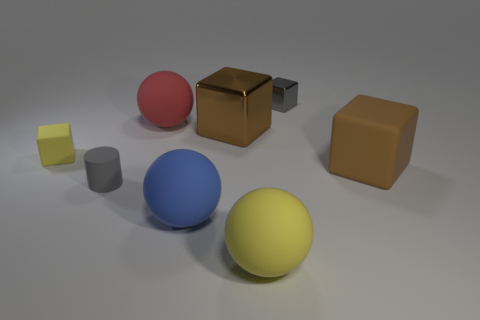There is a small object that is both to the right of the tiny yellow rubber object and behind the big matte block; what material is it made of? The small object in question, positioned to the right of the tiny yellow rubber object and behind the large matte block, is made of a metallic material. Its smooth surface reflects light differently than the matte textures around it, indicating it likely consists of metal. 